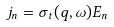Convert formula to latex. <formula><loc_0><loc_0><loc_500><loc_500>j _ { n } = \sigma _ { t } ( q , \omega ) E _ { n }</formula> 